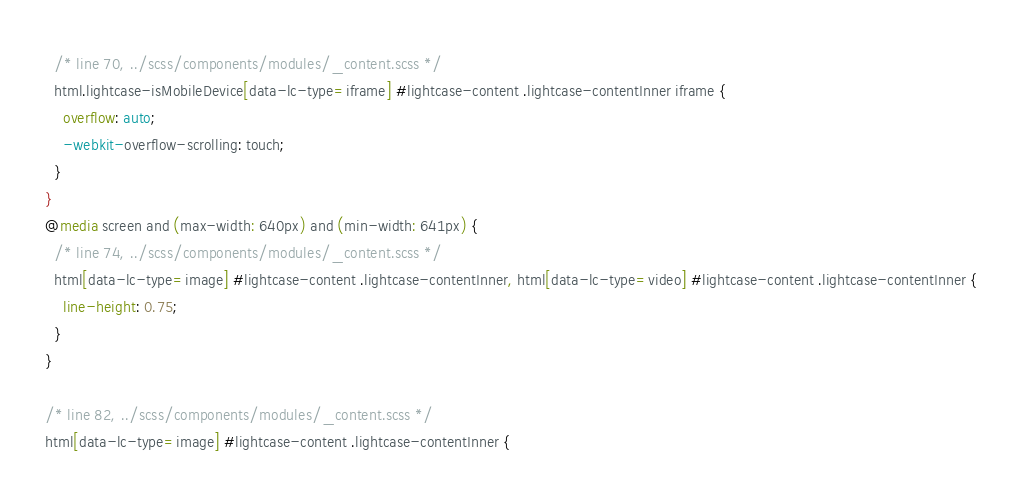<code> <loc_0><loc_0><loc_500><loc_500><_CSS_>  /* line 70, ../scss/components/modules/_content.scss */
  html.lightcase-isMobileDevice[data-lc-type=iframe] #lightcase-content .lightcase-contentInner iframe {
    overflow: auto;
    -webkit-overflow-scrolling: touch;
  }
}
@media screen and (max-width: 640px) and (min-width: 641px) {
  /* line 74, ../scss/components/modules/_content.scss */
  html[data-lc-type=image] #lightcase-content .lightcase-contentInner, html[data-lc-type=video] #lightcase-content .lightcase-contentInner {
    line-height: 0.75;
  }
}

/* line 82, ../scss/components/modules/_content.scss */
html[data-lc-type=image] #lightcase-content .lightcase-contentInner {</code> 